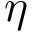<formula> <loc_0><loc_0><loc_500><loc_500>\eta</formula> 